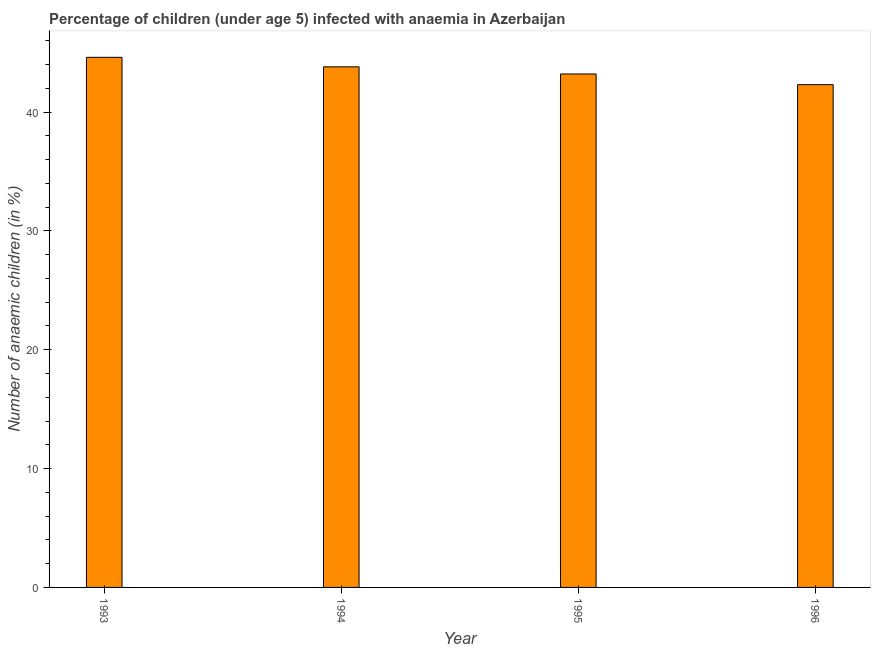Does the graph contain grids?
Keep it short and to the point. No. What is the title of the graph?
Ensure brevity in your answer.  Percentage of children (under age 5) infected with anaemia in Azerbaijan. What is the label or title of the Y-axis?
Give a very brief answer. Number of anaemic children (in %). What is the number of anaemic children in 1996?
Provide a succinct answer. 42.3. Across all years, what is the maximum number of anaemic children?
Give a very brief answer. 44.6. Across all years, what is the minimum number of anaemic children?
Give a very brief answer. 42.3. What is the sum of the number of anaemic children?
Make the answer very short. 173.9. What is the average number of anaemic children per year?
Offer a very short reply. 43.48. What is the median number of anaemic children?
Offer a very short reply. 43.5. What is the ratio of the number of anaemic children in 1994 to that in 1995?
Your answer should be very brief. 1.01. Is the number of anaemic children in 1994 less than that in 1996?
Your answer should be very brief. No. Is the difference between the number of anaemic children in 1994 and 1996 greater than the difference between any two years?
Provide a short and direct response. No. What is the difference between the highest and the second highest number of anaemic children?
Make the answer very short. 0.8. Is the sum of the number of anaemic children in 1994 and 1995 greater than the maximum number of anaemic children across all years?
Your answer should be compact. Yes. What is the difference between the highest and the lowest number of anaemic children?
Ensure brevity in your answer.  2.3. How many bars are there?
Your answer should be compact. 4. What is the Number of anaemic children (in %) in 1993?
Give a very brief answer. 44.6. What is the Number of anaemic children (in %) in 1994?
Provide a short and direct response. 43.8. What is the Number of anaemic children (in %) of 1995?
Offer a very short reply. 43.2. What is the Number of anaemic children (in %) in 1996?
Your answer should be very brief. 42.3. What is the difference between the Number of anaemic children (in %) in 1993 and 1994?
Your answer should be very brief. 0.8. What is the difference between the Number of anaemic children (in %) in 1993 and 1995?
Your response must be concise. 1.4. What is the difference between the Number of anaemic children (in %) in 1994 and 1995?
Give a very brief answer. 0.6. What is the difference between the Number of anaemic children (in %) in 1994 and 1996?
Keep it short and to the point. 1.5. What is the difference between the Number of anaemic children (in %) in 1995 and 1996?
Give a very brief answer. 0.9. What is the ratio of the Number of anaemic children (in %) in 1993 to that in 1994?
Your answer should be compact. 1.02. What is the ratio of the Number of anaemic children (in %) in 1993 to that in 1995?
Your answer should be compact. 1.03. What is the ratio of the Number of anaemic children (in %) in 1993 to that in 1996?
Ensure brevity in your answer.  1.05. What is the ratio of the Number of anaemic children (in %) in 1994 to that in 1996?
Offer a terse response. 1.03. What is the ratio of the Number of anaemic children (in %) in 1995 to that in 1996?
Offer a terse response. 1.02. 